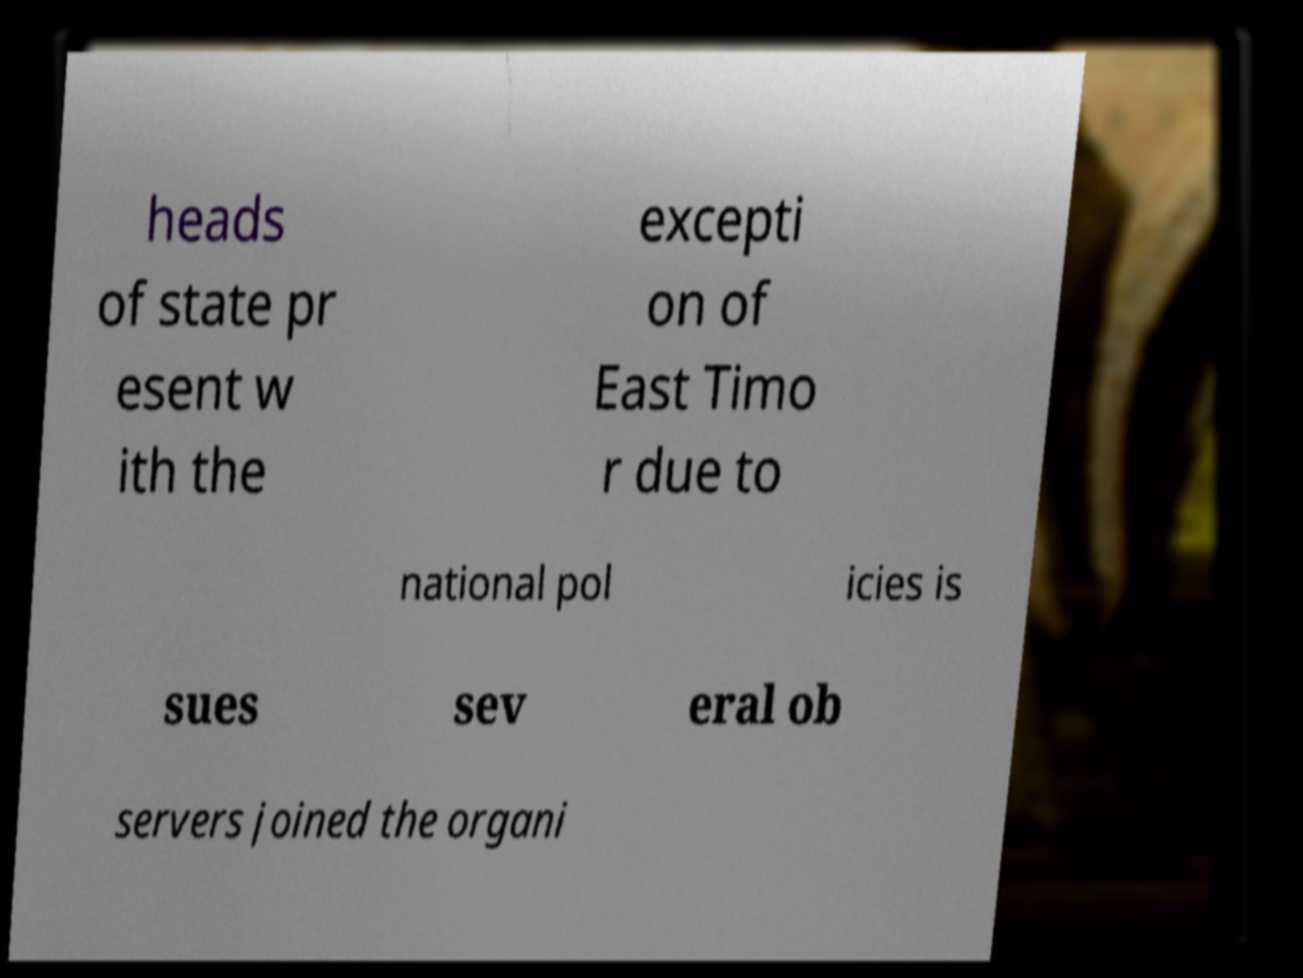For documentation purposes, I need the text within this image transcribed. Could you provide that? heads of state pr esent w ith the excepti on of East Timo r due to national pol icies is sues sev eral ob servers joined the organi 